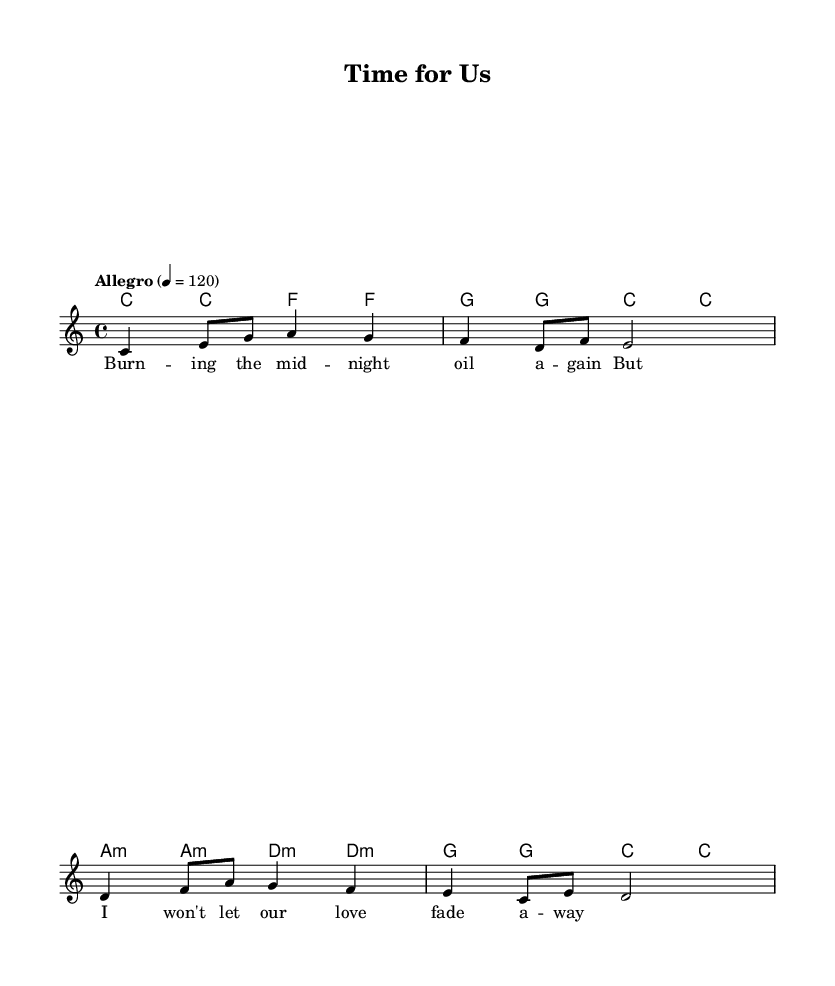What is the key signature of this music? The key signature is indicated at the beginning of the staff, and it is C major, which has no sharps or flats.
Answer: C major What is the time signature of this music? The time signature is shown at the beginning of the score, indicating how many beats are in each measure, which is 4/4.
Answer: 4/4 What is the tempo marking for this piece? The tempo marking indicates the speed of the music and is marked as "Allegro," with a metronome marking of 120 beats per minute.
Answer: Allegro, 120 What type of song structure is used in this sheet music? The song structure follows a basic verse format, focusing on lyrical content that reflects personal experiences and emotions, specifically about balancing work and personal life.
Answer: Verse How many measures are in the melody section? By counting the number of bar lines in the melody part, there are a total of four measures in this section.
Answer: Four What is the primary emotion conveyed in the lyrics? The lyrics describe a struggle between work demands and maintaining a relationship, showcasing feelings of resilience and commitment despite challenges.
Answer: Resilience What instrument is this sheet music intended for? The music is arranged for a piano, as indicated by the presence of both melody and chord symbols typically used for piano accompaniment.
Answer: Piano 